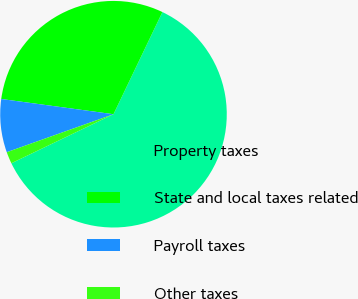<chart> <loc_0><loc_0><loc_500><loc_500><pie_chart><fcel>Property taxes<fcel>State and local taxes related<fcel>Payroll taxes<fcel>Other taxes<nl><fcel>60.77%<fcel>29.96%<fcel>7.59%<fcel>1.68%<nl></chart> 